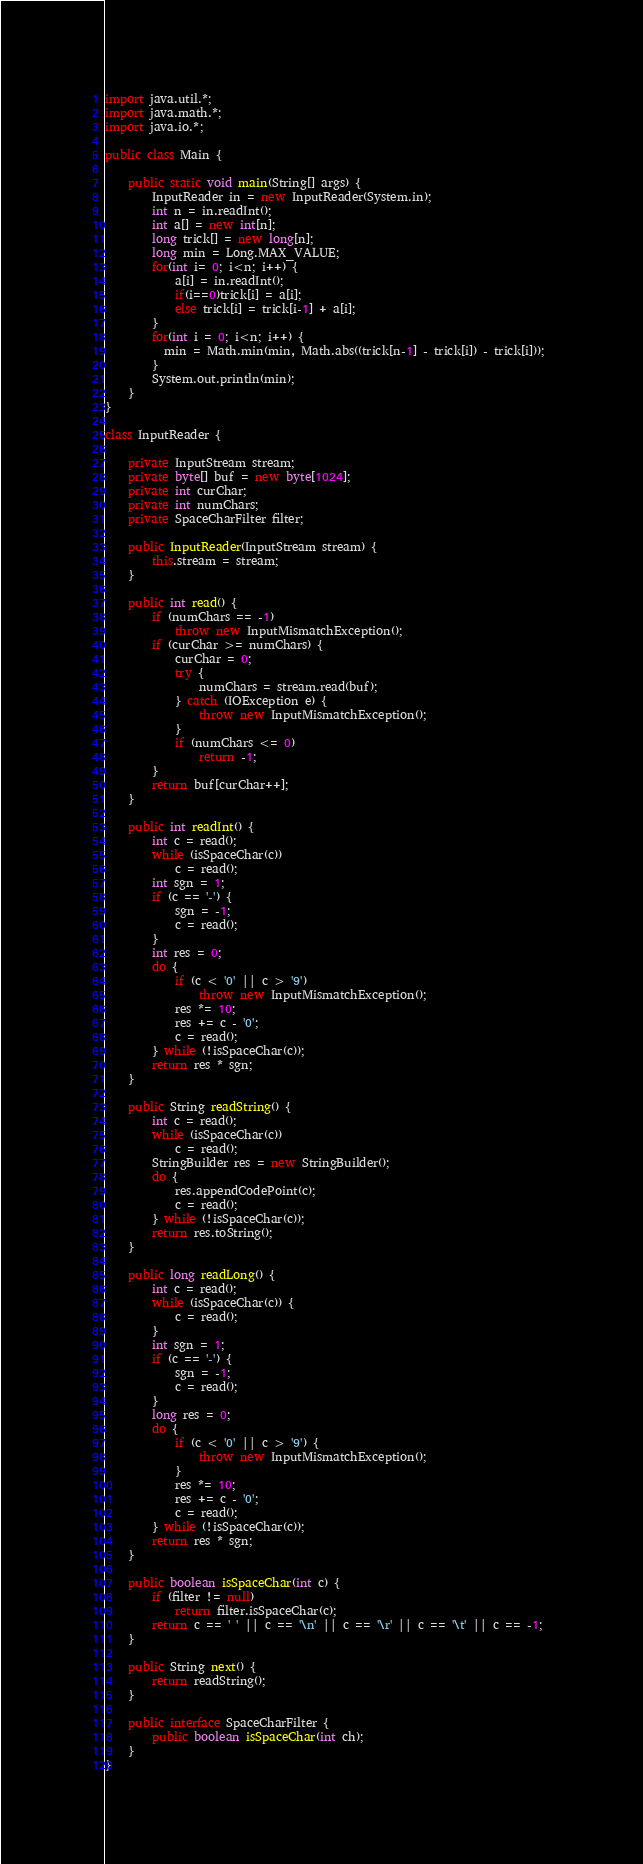<code> <loc_0><loc_0><loc_500><loc_500><_Java_>import java.util.*;
import java.math.*; 
import java.io.*;

public class Main {
    
	public static void main(String[] args) {
		InputReader in = new InputReader(System.in);
		int n = in.readInt();
		int a[] = new int[n]; 
		long trick[] = new long[n]; 
		long min = Long.MAX_VALUE; 
		for(int i= 0; i<n; i++) {
			a[i] = in.readInt();
			if(i==0)trick[i] = a[i]; 
			else trick[i] = trick[i-1] + a[i]; 
		}
		for(int i = 0; i<n; i++) {
		  min = Math.min(min, Math.abs((trick[n-1] - trick[i]) - trick[i])); 
		}
		System.out.println(min); 
	}
}

class InputReader {

	private InputStream stream;
	private byte[] buf = new byte[1024];
	private int curChar;
	private int numChars;
	private SpaceCharFilter filter;

	public InputReader(InputStream stream) {
		this.stream = stream;
	}

	public int read() {
		if (numChars == -1)
			throw new InputMismatchException();
		if (curChar >= numChars) {
			curChar = 0;
			try {
				numChars = stream.read(buf);
			} catch (IOException e) {
				throw new InputMismatchException();
			}
			if (numChars <= 0)
				return -1;
		}
		return buf[curChar++];
	}

	public int readInt() {
		int c = read();
		while (isSpaceChar(c))
			c = read();
		int sgn = 1;
		if (c == '-') {
			sgn = -1;
			c = read();
		}
		int res = 0;
		do {
			if (c < '0' || c > '9')
				throw new InputMismatchException();
			res *= 10;
			res += c - '0';
			c = read();
		} while (!isSpaceChar(c));
		return res * sgn;
	}

	public String readString() {
		int c = read();
		while (isSpaceChar(c))
			c = read();
		StringBuilder res = new StringBuilder();
		do {
			res.appendCodePoint(c);
			c = read();
		} while (!isSpaceChar(c));
		return res.toString();
	}

	public long readLong() {
		int c = read();
		while (isSpaceChar(c)) {
			c = read();
		}
		int sgn = 1;
		if (c == '-') {
			sgn = -1;
			c = read();
		}
		long res = 0;
		do {
			if (c < '0' || c > '9') {
				throw new InputMismatchException();
			}
			res *= 10;
			res += c - '0';
			c = read();
		} while (!isSpaceChar(c));
		return res * sgn;
	}
	
	public boolean isSpaceChar(int c) {
		if (filter != null)
			return filter.isSpaceChar(c);
		return c == ' ' || c == '\n' || c == '\r' || c == '\t' || c == -1;
	}

	public String next() {
		return readString();
	}

	public interface SpaceCharFilter {
		public boolean isSpaceChar(int ch);
	}
}
</code> 